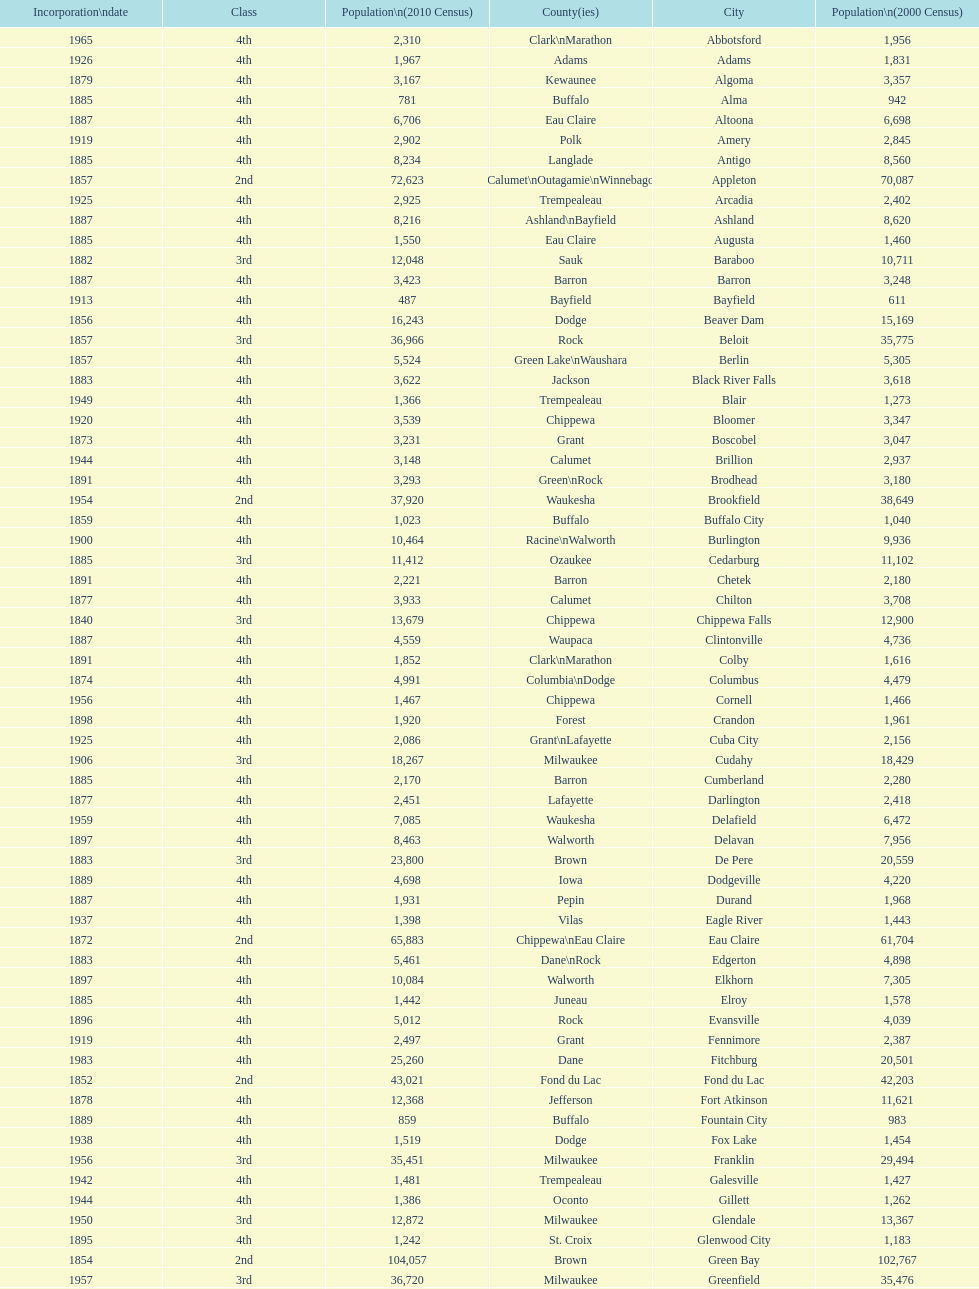Which city in wisconsin is the most populous, based on the 2010 census? Milwaukee. 